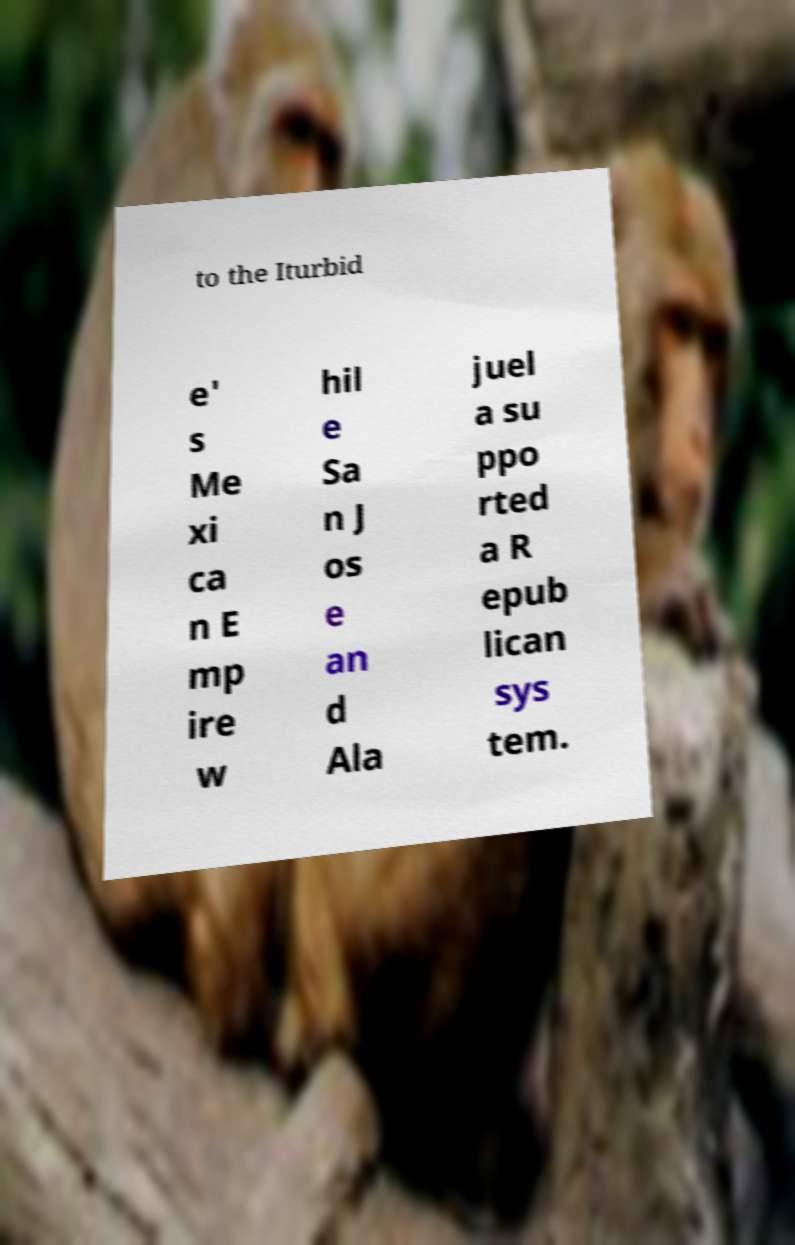I need the written content from this picture converted into text. Can you do that? to the Iturbid e' s Me xi ca n E mp ire w hil e Sa n J os e an d Ala juel a su ppo rted a R epub lican sys tem. 